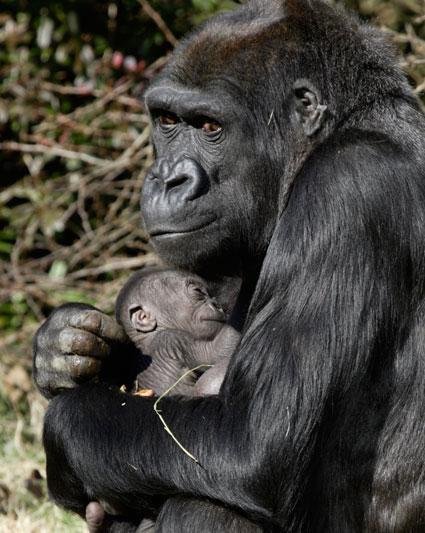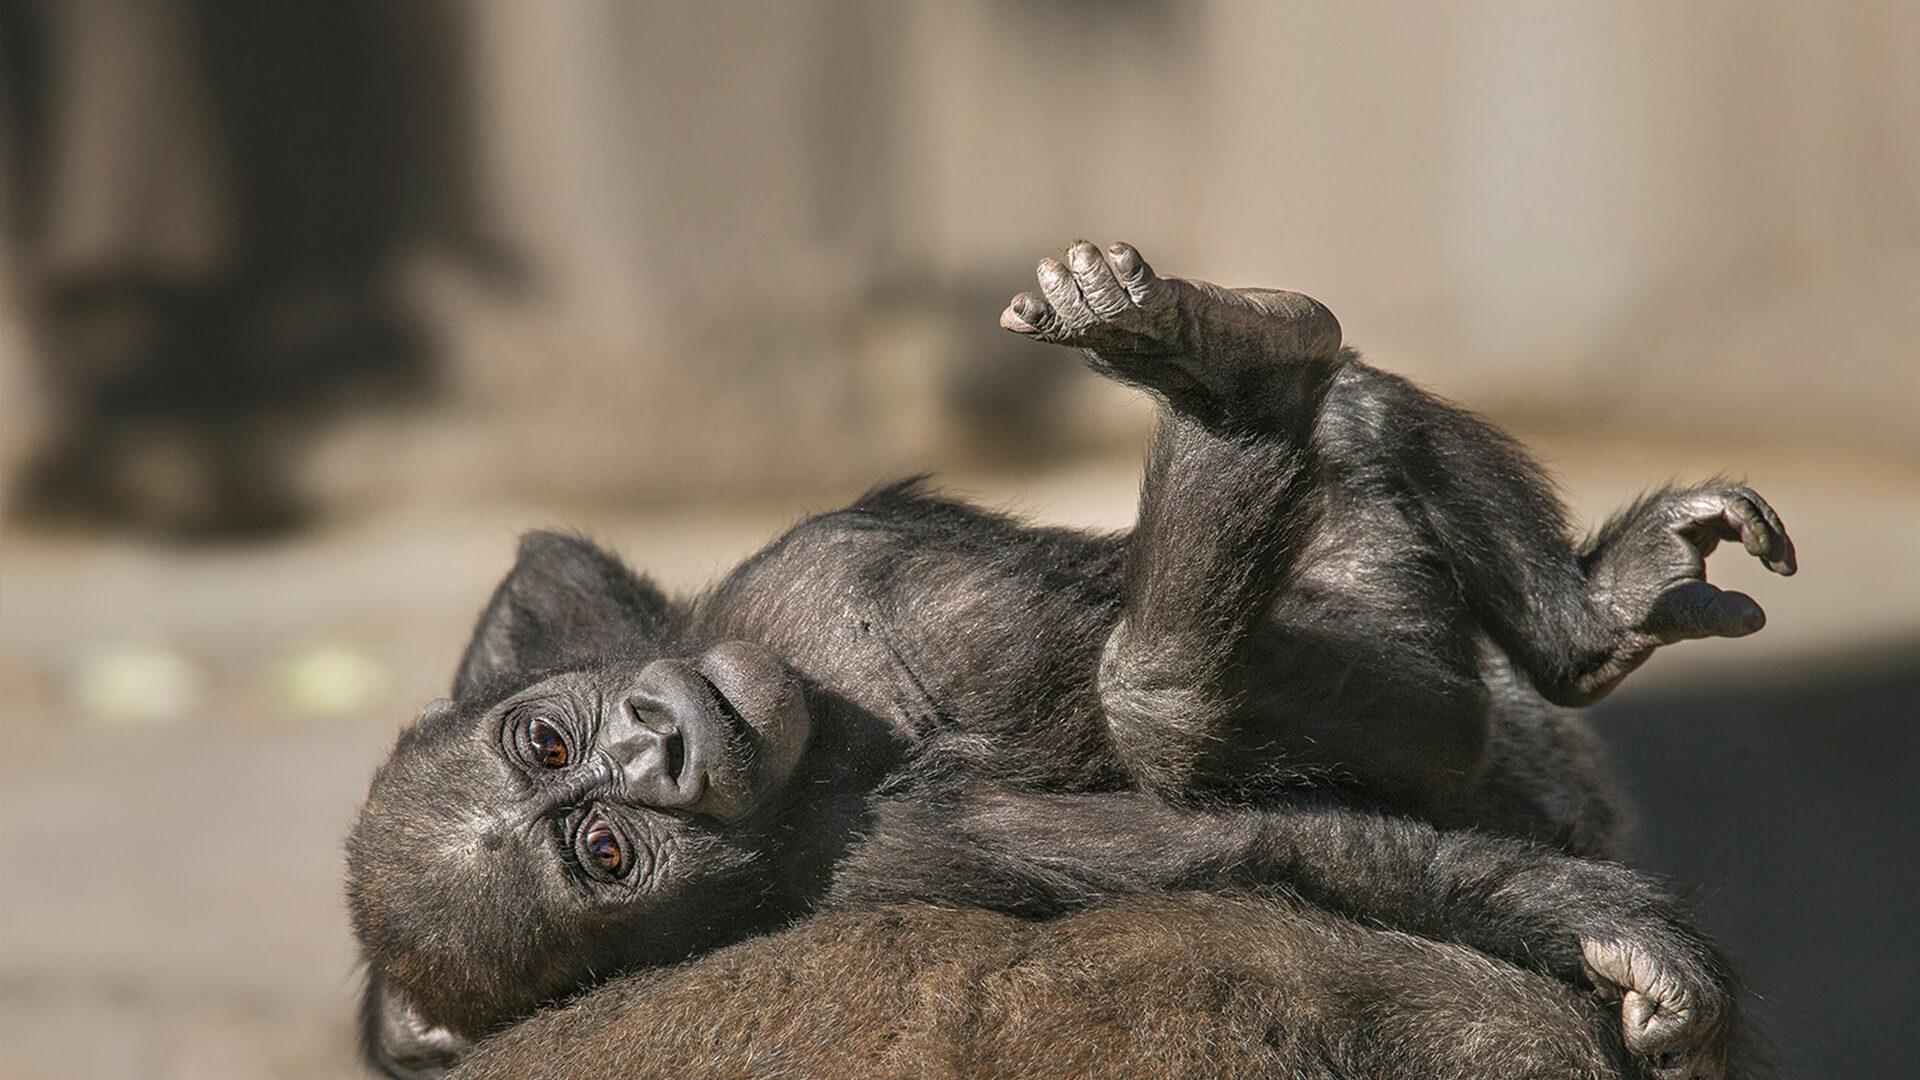The first image is the image on the left, the second image is the image on the right. Evaluate the accuracy of this statement regarding the images: "A single young primate is lying down in the image on the right.". Is it true? Answer yes or no. Yes. The first image is the image on the left, the second image is the image on the right. For the images shown, is this caption "An image shows an adult chimpanzee hugging a younger awake chimpanzee to its chest." true? Answer yes or no. No. 